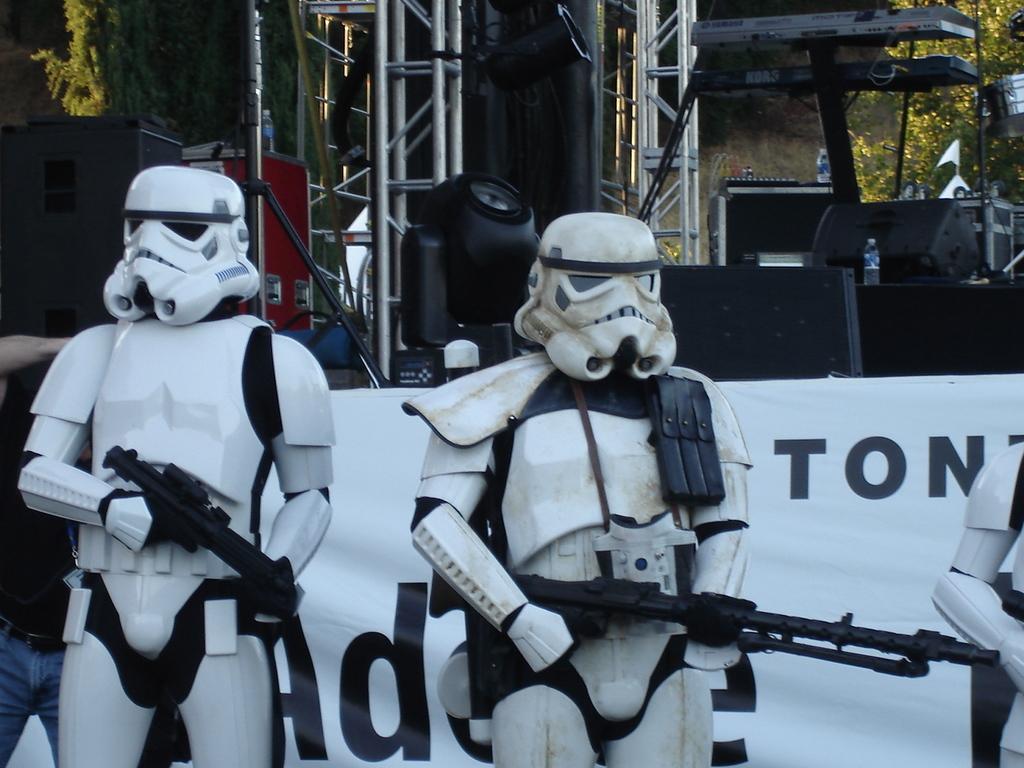Describe this image in one or two sentences. There are statues wearing helmets and holding gun. In the back there is a banner. Also there are poles, trees and bottles in the background. 